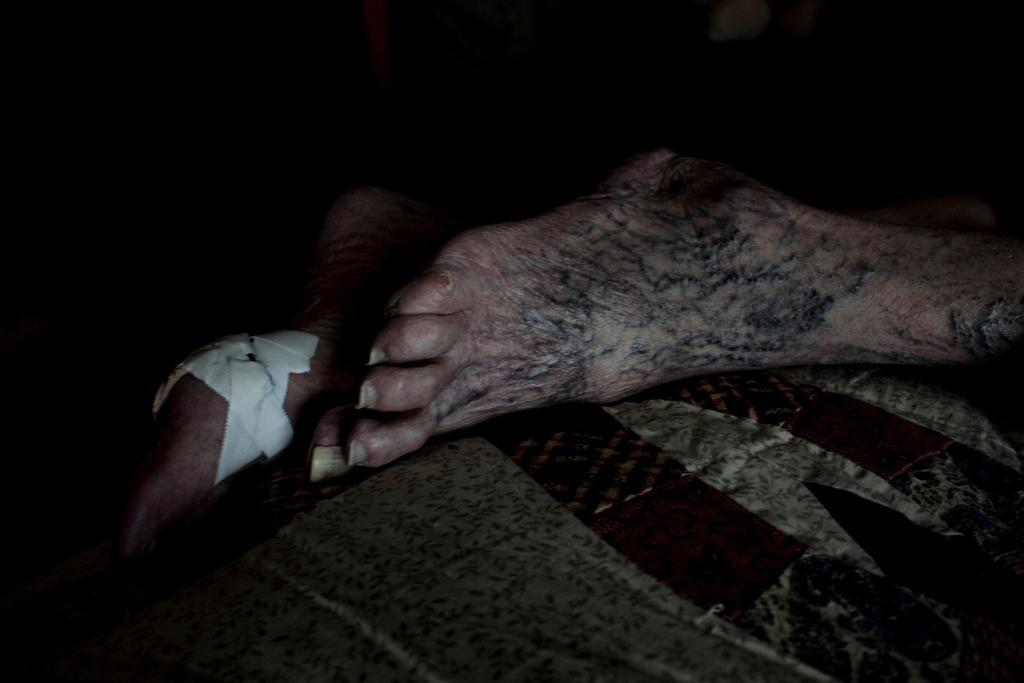What part of a person's body is visible in the image? The legs of a person are visible in the image. What type of bat is hanging from the kettle in the image? There is no bat or kettle present in the image; only the legs of a person are visible. 